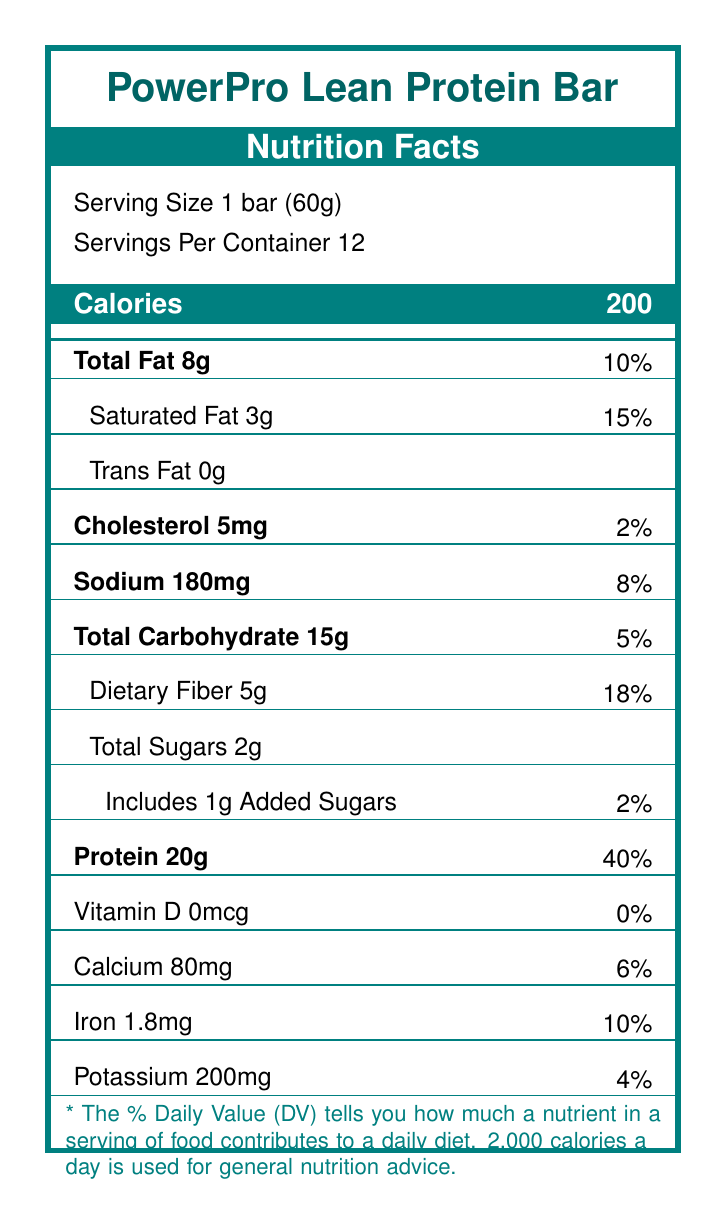what is the serving size for the PowerPro Lean Protein Bar? The serving size is specified directly under the product name as "Serving Size 1 bar (60g)".
Answer: 1 bar (60g) how many calories are in one serving of the PowerPro Lean Protein Bar? The calorie count is indicated in a separated box under the serving information.
Answer: 200 what is the amount of protein in one bar and its daily value percentage? Under the nutrient information, it is stated that one serving contains 20g of protein, which corresponds to 40% of the daily value.
Answer: 20g; 40% which nutrient has the highest daily value percentage in the PowerPro Lean Protein Bar? By comparing all the daily value percentages listed, protein has the highest percentage at 40%.
Answer: Protein, 40% how many grams of total carbohydrates are present in one PowerPro Lean Protein Bar? Under the nutrient information, the total carbohydrate content is stated as 15g.
Answer: 15g what is the amount of sodium in the bar as a percentage of the daily value? A. 2% B. 8% C. 10% D. 15% The sodium content is 180mg, which is 8% of the daily value.
Answer: B. 8% how many grams of saturated fat does the PowerPro Lean Protein Bar contain? The label indicates that saturated fat content is 3g, which is 15% of the daily value.
Answer: 3g what are the first three ingredients listed for the PowerPro Lean Protein Bar? The ingredients are listed in descending order by weight, and these are the first three.
Answer: Whey protein isolate, Milk protein isolate, Almonds is the PowerPro Lean Protein Bar gluten-free? There is no specific information about gluten content on the label, although it mentions potential cross-contamination with wheat.
Answer: Not enough information does the PowerPro Lean Protein Bar contain any artificial sweeteners or preservatives? According to the marketing claims, the bar contains no artificial sweeteners or preservatives.
Answer: No can the PowerPro Lean Protein Bar be a good choice for someone looking to increase their fiber intake? Why or why not? The bar contains 5g of dietary fiber, which is 18% of the daily value, making it a good option for increasing fiber intake.
Answer: Yes what is the main marketing point of the PowerPro Lean Protein Bar? The marketing claims emphasize 20g of protein, only 2g of sugar, and low net carbs.
Answer: High protein content with low sugar and carbs how much calcium does one bar provide and its percentage of the daily value? A. 0mcg; 0% B. 200mg; 4% C. 80mg; 6% D. 1.8mg; 10% The calcium content is 80mg, which is 6% of the daily value.
Answer: C. 80mg; 6% does the PowerPro Lean Protein Bar meet any specific dietary or allergen requirements? Under allergens, it states that the bar contains milk and almonds and may be processed in a facility that also processes soy, peanuts, and wheat.
Answer: It contains milk and tree nuts (almonds) and may contain traces of soy, peanuts, and wheat summarize the main nutritional benefits of the PowerPro Lean Protein Bar. This summary captures the main nutritional advantages, highlighting the high protein content and low sugar/carb profile, along with the other notable benefits.
Answer: The PowerPro Lean Protein Bar is a high-protein, low-carb snack designed for fitness enthusiasts. It provides 20g of protein, 200 calories, 8g of total fat, and 5g of dietary fiber per serving. The bar also contains minimal sugars and no artificial sweeteners or preservatives. how does the brand emphasize its credibility in the nutrition and fitness market? The storytelling elements mention the brand's foundation by fitness enthusiasts and highlight customer testimonials to build credibility.
Answer: Through its brand story and testimonials from fitness enthusiasts like Sarah, a CrossFit competitor 